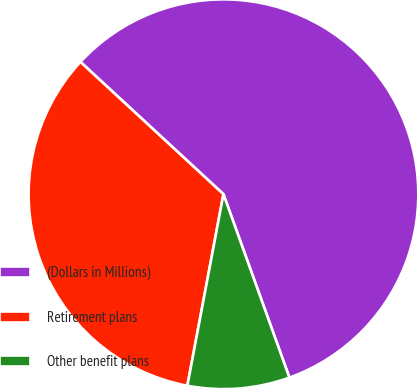Convert chart. <chart><loc_0><loc_0><loc_500><loc_500><pie_chart><fcel>(Dollars in Millions)<fcel>Retirement plans<fcel>Other benefit plans<nl><fcel>57.62%<fcel>33.91%<fcel>8.46%<nl></chart> 